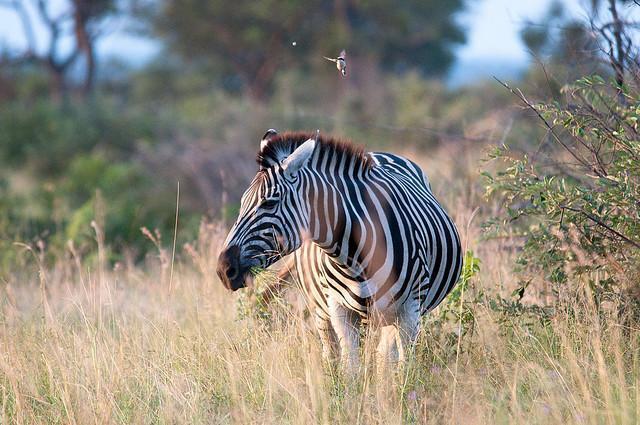How many people are in the boat?
Give a very brief answer. 0. 